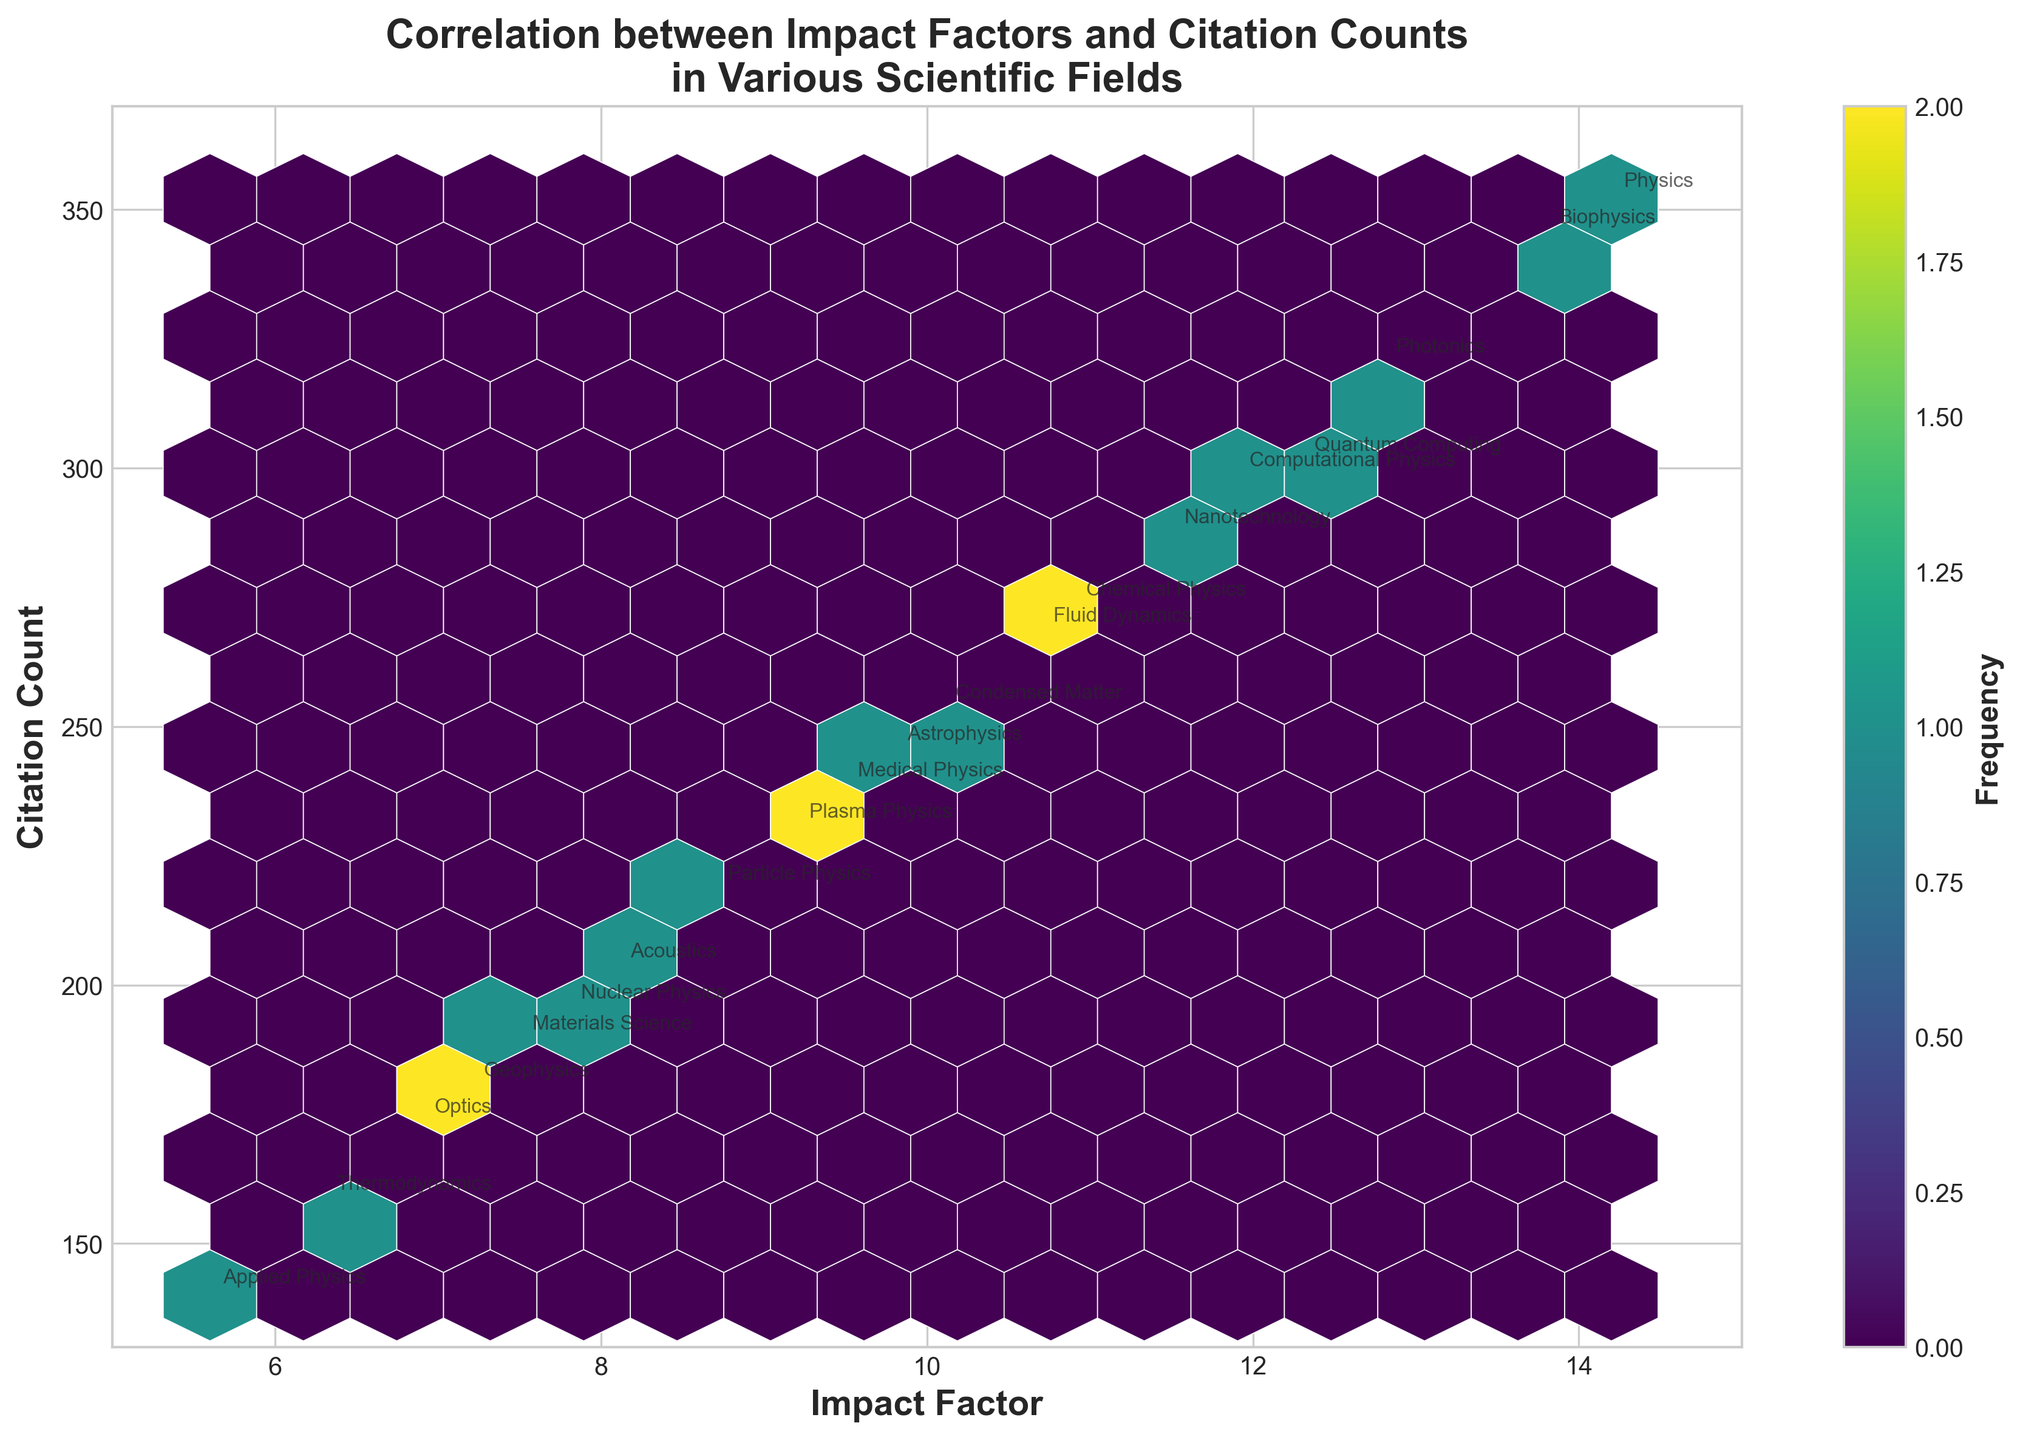What is the main title of the plot? The main title is located at the top of the plot, in bold text. It reads "Correlation between Impact Factors and Citation Counts in Various Scientific Fields"
Answer: Correlation between Impact Factors and Citation Counts in Various Scientific Fields What are the x and y axes representing in the plot? The x-axis represents the Impact Factor of publications, and the y-axis represents the Citation Count of publications. These labels are found at the bottom and left sides of the plot, respectively
Answer: Impact Factor and Citation Count How many scientific fields are annotated directly on the plot? By counting the number of annotations in the form of text labels, we can determine how many scientific fields are represented. There are labels for each of the 20 data points.
Answer: 20 Which scientific field has the highest impact factor? By looking at the x-axis where the impact factor is the highest (15), we can see that the field corresponding to it is Physics with an impact factor of 14.2.
Answer: Physics What color map is used in the hexbin plot, and what does the color intensity represent? The color map used is 'viridis,' as indicated by the color progression from yellow to blue. Darker colors represent higher frequencies of data points within those hexagonal bins.
Answer: viridis; frequency of data points Which scientific field has a citation count around 200 and what is its impact factor? By identifying the annotation close to the citation count value of 200 on the y-axis, we find Acoustics with an impact factor of 8.1.
Answer: Acoustics; 8.1 Does there appear to be a general trend or correlation between Impact Factor and Citation Count in the data? Examining the distribution of the hexagons, it appears that there tends to be a positive trend, indicating that higher impact factors generally correspond to higher citation counts, although there are some deviations.
Answer: Yes, positive trend How does the citation count for Biophysics compare to that of Quantum Computing? By comparing the positions of the annotations for Biophysics and Quantum Computing, Biophysics has a higher citation count (345) than Quantum Computing (301).
Answer: Biophysics has a higher citation count In which impact factor range do most publications fall, and what does this imply about the dataset? Observing the density of the hexagons, most publications have impact factors between 8 and 12. This can be inferred from the concentration of darker-colored hexagons within this range.
Answer: 8 to 12; most publications have moderate impact factors Which fields have both high impact factors and high citation counts? Fields with high impact factors (above 12) and high citation counts (above 300) include Physics and Biophysics. We can infer this by looking at annotations in this range.
Answer: Physics, Biophysics 